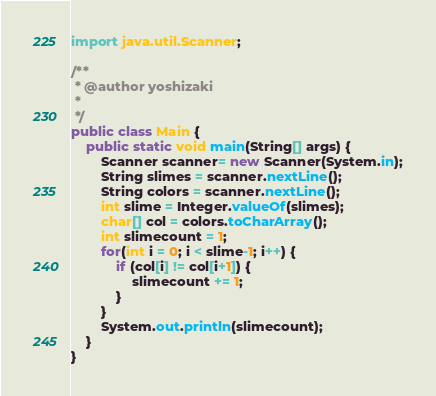Convert code to text. <code><loc_0><loc_0><loc_500><loc_500><_Java_>
import java.util.Scanner;

/**
 * @author yoshizaki
 *
 */
public class Main {
    public static void main(String[] args) {
        Scanner scanner= new Scanner(System.in);
        String slimes = scanner.nextLine();
        String colors = scanner.nextLine();
        int slime = Integer.valueOf(slimes);
        char[] col = colors.toCharArray();
        int slimecount = 1;
        for(int i = 0; i < slime-1; i++) {
            if (col[i] != col[i+1]) {
                slimecount += 1;
            }
        }
        System.out.println(slimecount);
    }
}
</code> 